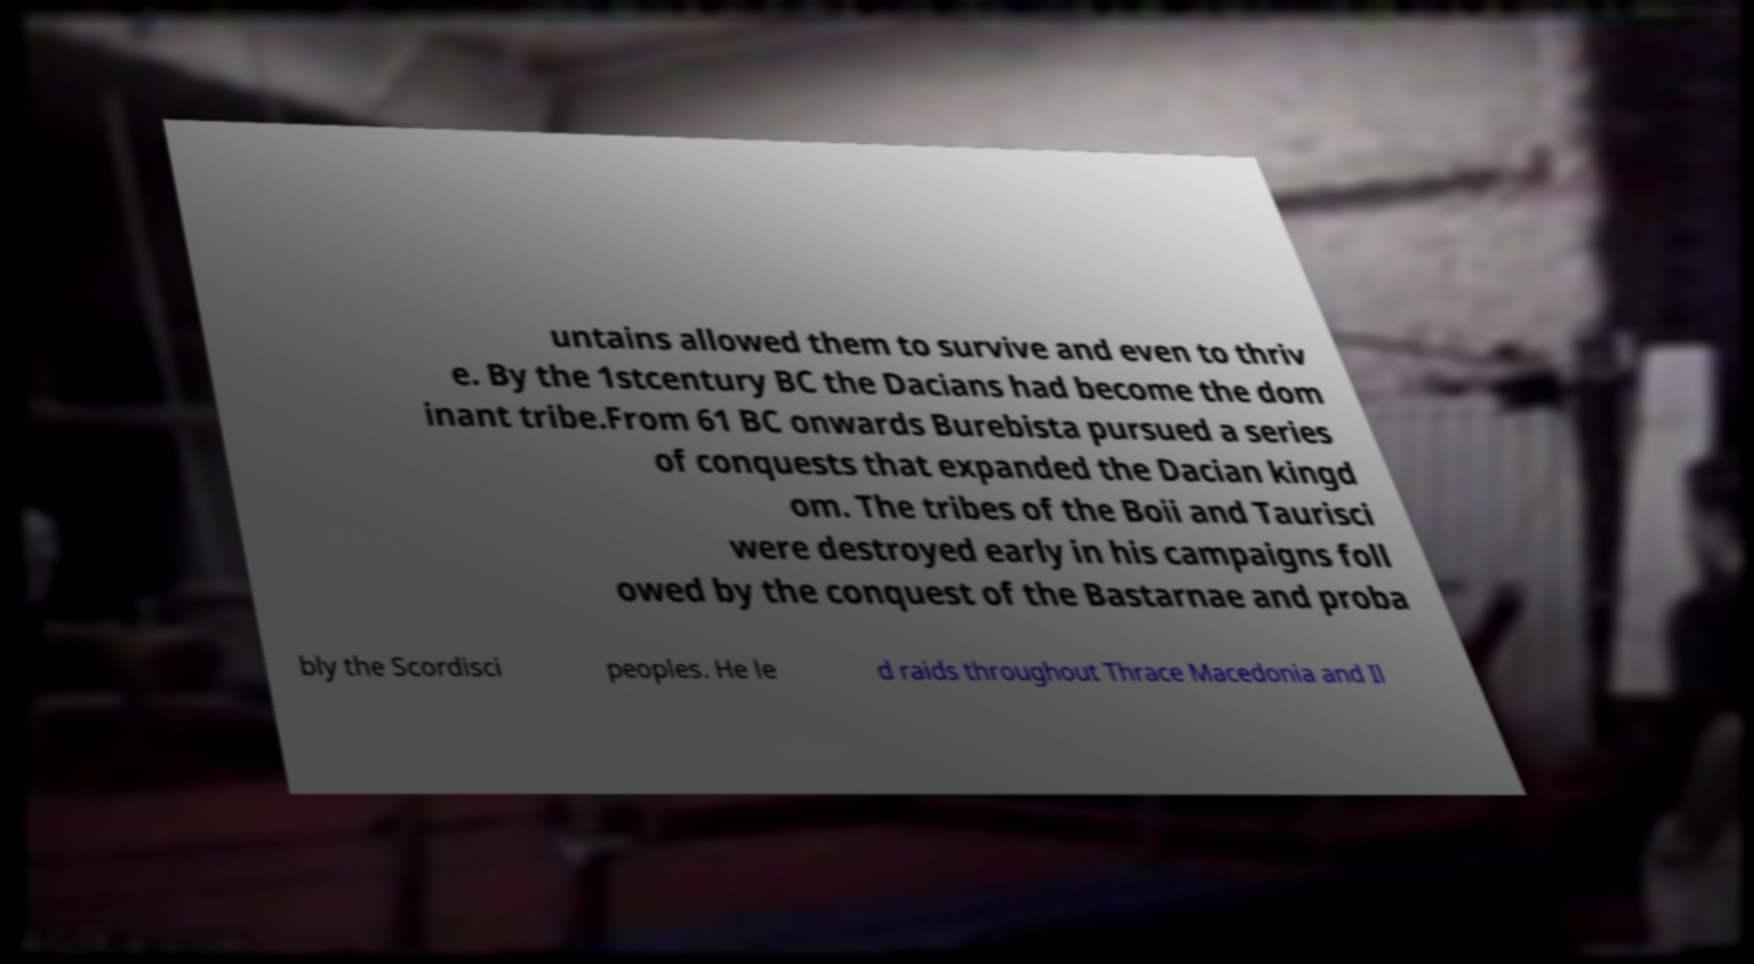What messages or text are displayed in this image? I need them in a readable, typed format. untains allowed them to survive and even to thriv e. By the 1stcentury BC the Dacians had become the dom inant tribe.From 61 BC onwards Burebista pursued a series of conquests that expanded the Dacian kingd om. The tribes of the Boii and Taurisci were destroyed early in his campaigns foll owed by the conquest of the Bastarnae and proba bly the Scordisci peoples. He le d raids throughout Thrace Macedonia and Il 